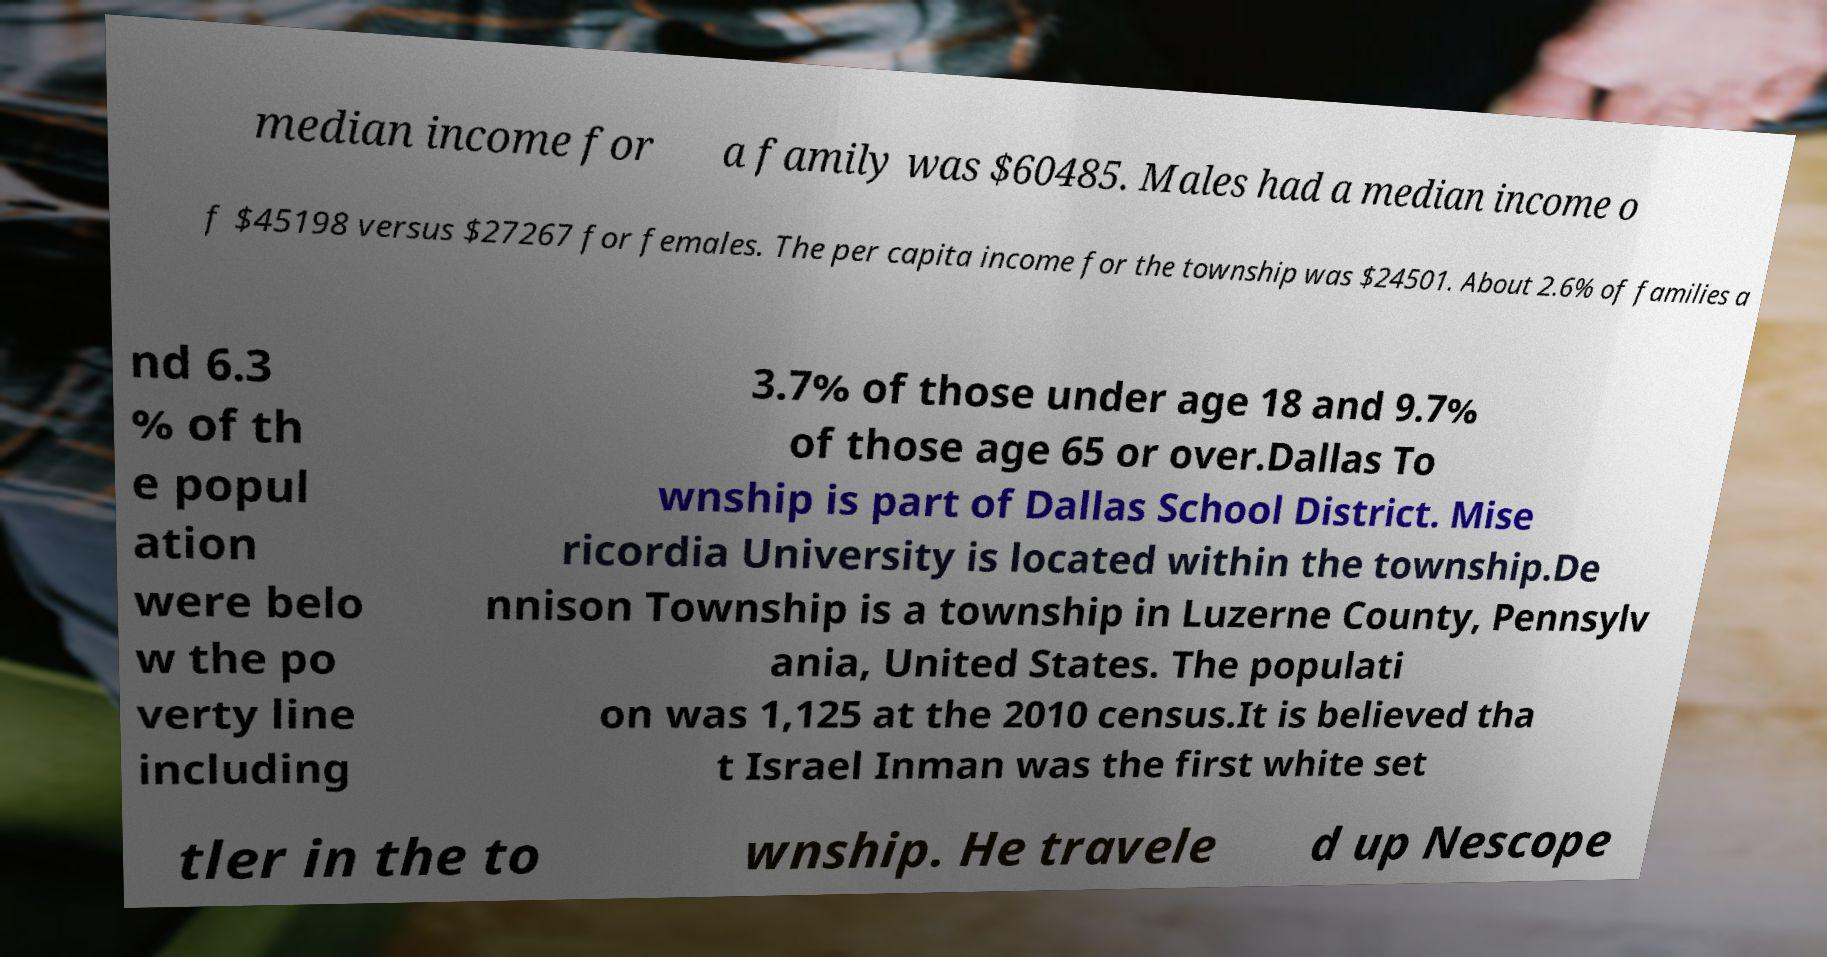For documentation purposes, I need the text within this image transcribed. Could you provide that? median income for a family was $60485. Males had a median income o f $45198 versus $27267 for females. The per capita income for the township was $24501. About 2.6% of families a nd 6.3 % of th e popul ation were belo w the po verty line including 3.7% of those under age 18 and 9.7% of those age 65 or over.Dallas To wnship is part of Dallas School District. Mise ricordia University is located within the township.De nnison Township is a township in Luzerne County, Pennsylv ania, United States. The populati on was 1,125 at the 2010 census.It is believed tha t Israel Inman was the first white set tler in the to wnship. He travele d up Nescope 